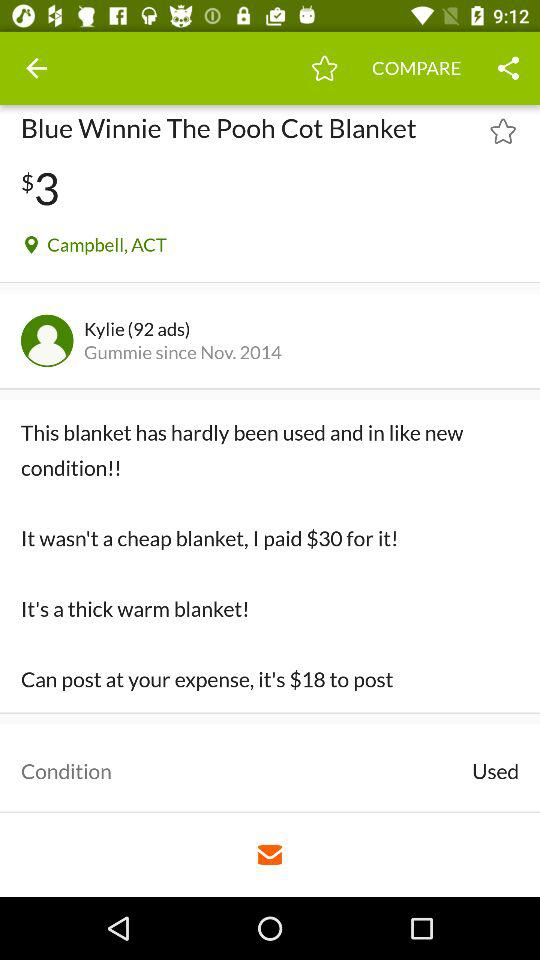Which applications are available for sharing information about the product?
When the provided information is insufficient, respond with <no answer>. <no answer> 